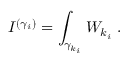<formula> <loc_0><loc_0><loc_500><loc_500>I ^ { ( \gamma _ { i } ) } = \int _ { { \gamma } _ { k _ { i } } } W _ { k _ { i } } \, .</formula> 